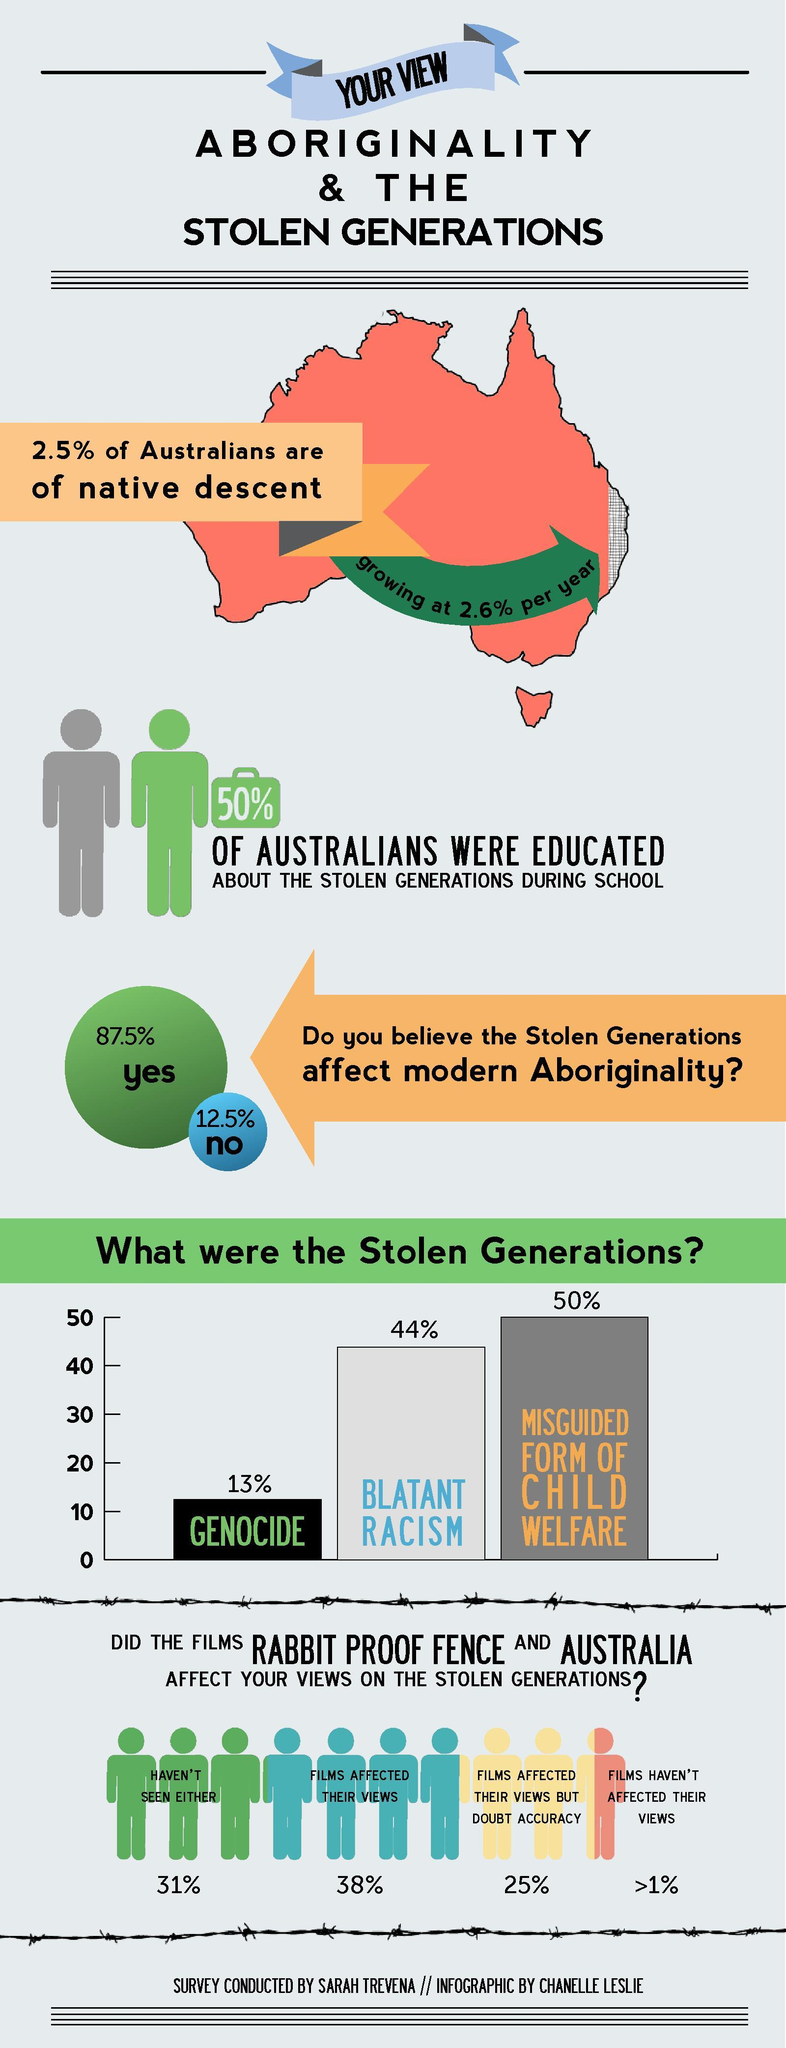Give some essential details in this illustration. The top reason for the Stolen Generations was the misguided form of child welfare. Thirty-eight percent of people were affected by the films. 